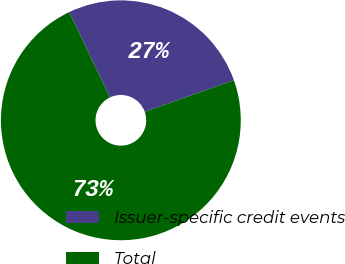Convert chart to OTSL. <chart><loc_0><loc_0><loc_500><loc_500><pie_chart><fcel>Issuer-specific credit events<fcel>Total<nl><fcel>26.67%<fcel>73.33%<nl></chart> 